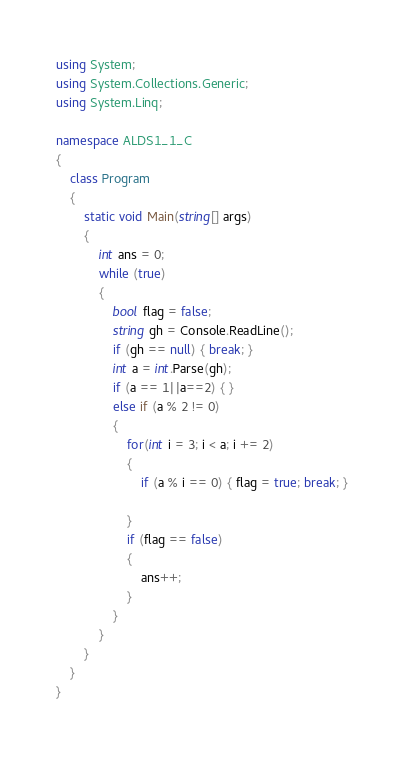Convert code to text. <code><loc_0><loc_0><loc_500><loc_500><_C#_>using System;
using System.Collections.Generic;
using System.Linq;

namespace ALDS1_1_C
{
    class Program
    {
        static void Main(string[] args)
        {
            int ans = 0;
            while (true)
            {
                bool flag = false;
                string gh = Console.ReadLine();
                if (gh == null) { break; }
                int a = int.Parse(gh);
                if (a == 1||a==2) { }
                else if (a % 2 != 0)                
                {
                    for(int i = 3; i < a; i += 2)
                    {
                        if (a % i == 0) { flag = true; break; }

                    }
                    if (flag == false)
                    {
                        ans++;
                    }
                }
            }
        }
    }
}</code> 